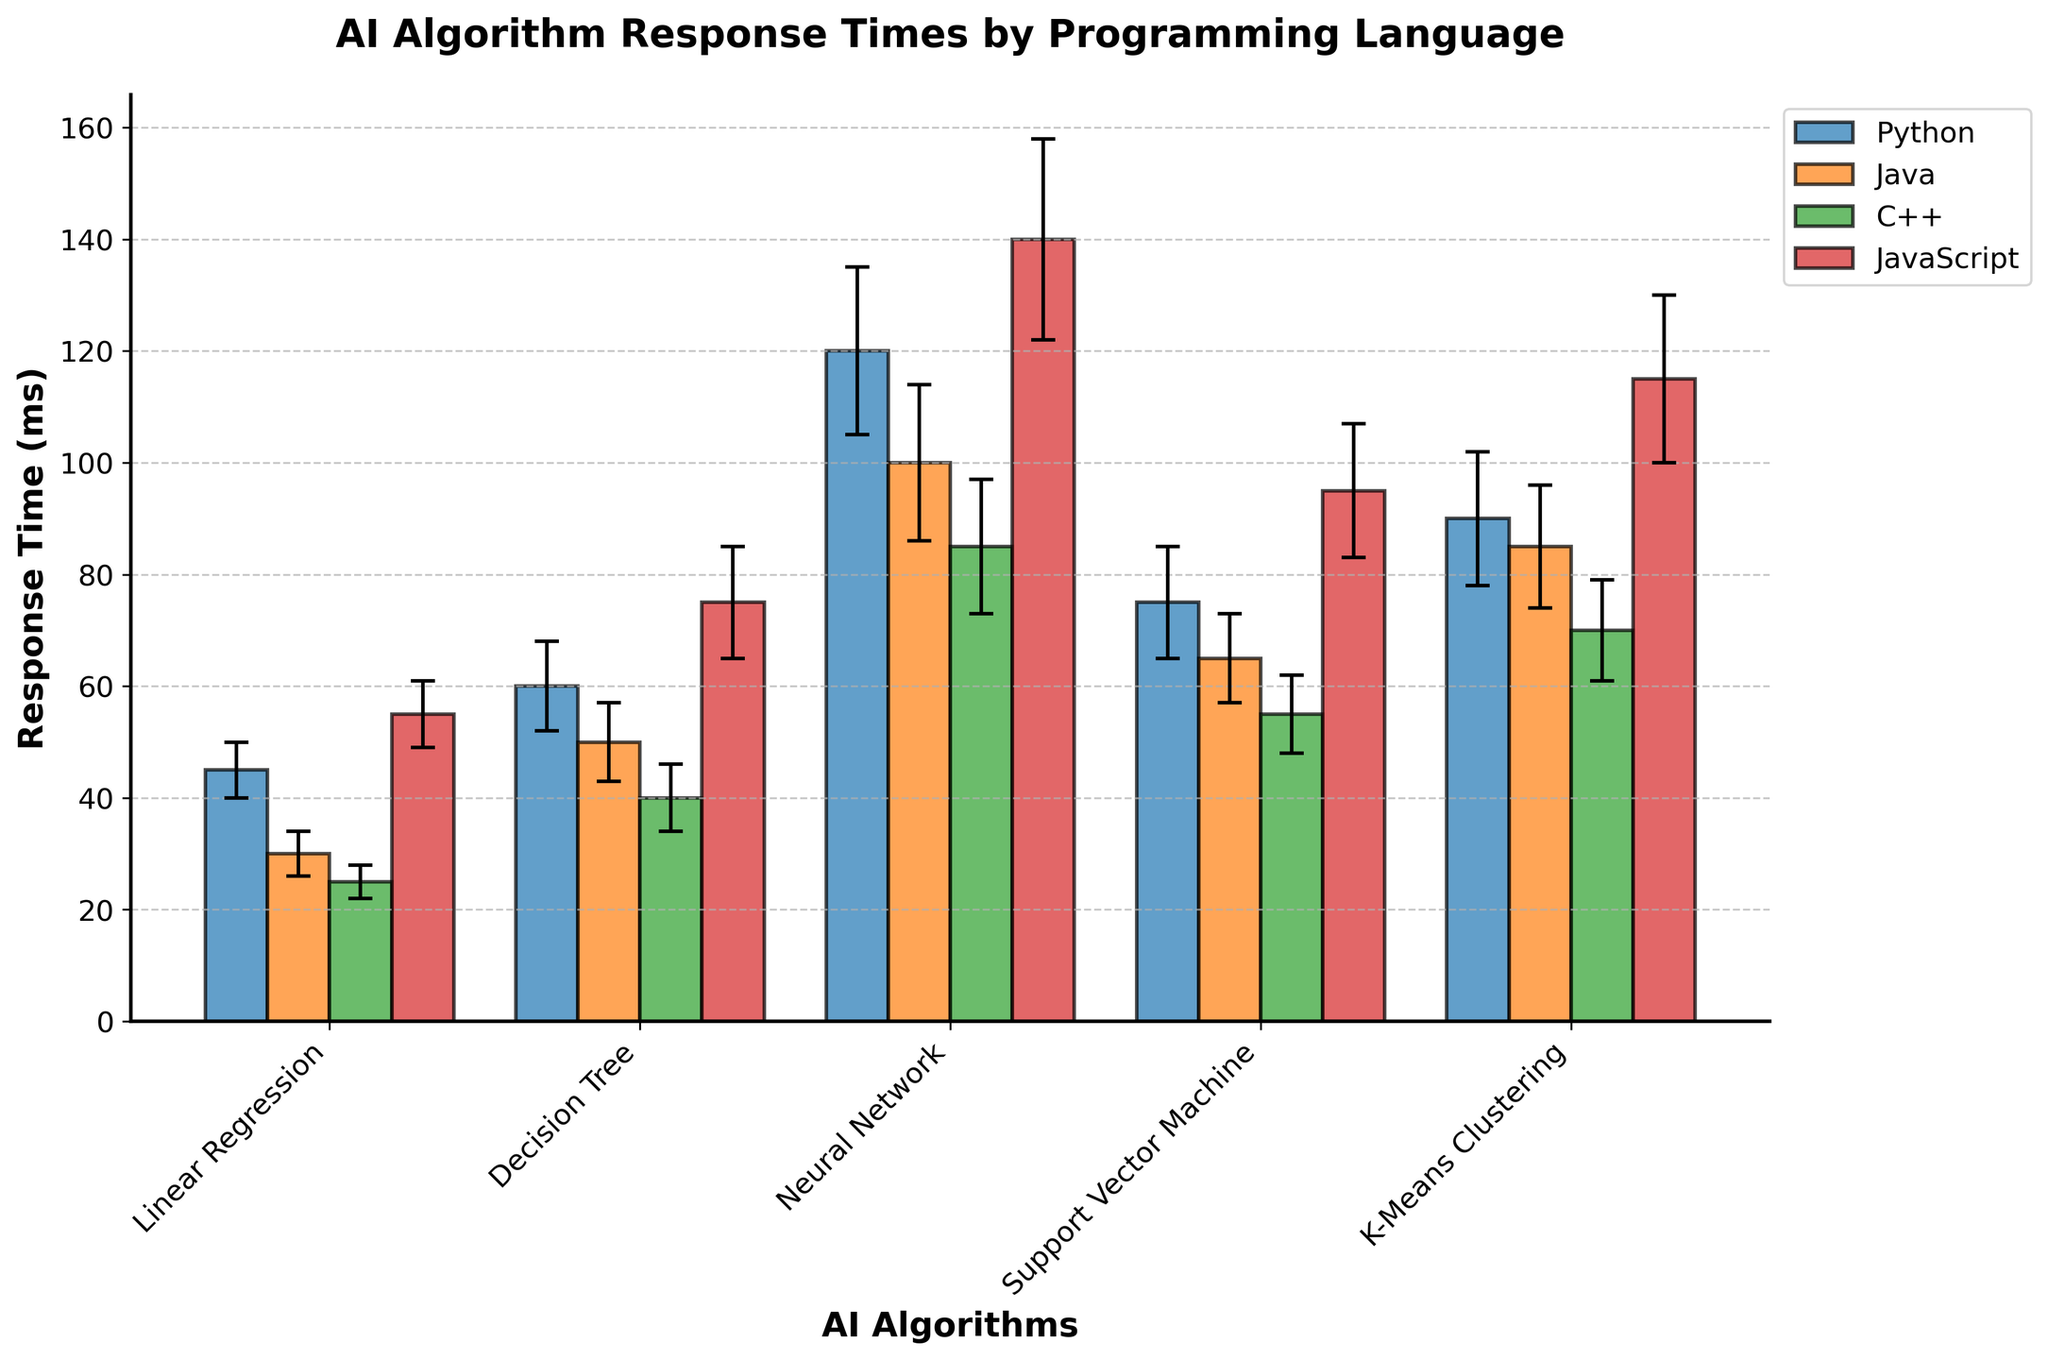What is the title of the figure? The title is at the top of the figure. It reads "AI Algorithm Response Times by Programming Language".
Answer: AI Algorithm Response Times by Programming Language Which language has the highest mean response time for the Neural Network algorithm? From the plot, the bar representing JavaScript for the Neural Network algorithm is the highest among the four languages.
Answer: JavaScript What is the mean response time of Java for the K-Means Clustering algorithm? The plot shows the height of the bar representing Java for the K-Means Clustering algorithm, which is aligned with the y-axis value at 85 ms.
Answer: 85 ms How much higher is the mean response time of Python compared to C++ for the Support Vector Machine algorithm? For Python, the mean response time for Support Vector Machine is 75 ms, and for C++, it is 55 ms. The difference is 75 ms - 55 ms = 20 ms.
Answer: 20 ms Which algorithm has the smallest standard deviation in response time for all four languages? By inspecting the error bars for each algorithm, the Linear Regression algorithm has the smallest error bars, indicating the smallest standard deviation across all languages.
Answer: Linear Regression Which language shows the greatest variability in mean response times across all algorithms? JavaScript shows the largest error bars across most algorithms, indicating the greatest variability in mean response times.
Answer: JavaScript For the Decision Tree algorithm, which language has the least response time, and what is its value? The plot shows that C++ has the shortest bar for the Decision Tree algorithm, indicating the least response time. The value is aligned with the y-axis at 40 ms.
Answer: C++, 40 ms Among the Linear Regression and K-Means Clustering algorithms, which one has the higher mean response time for the language Java? For Java, the Linear Regression mean response time is 30 ms, and the K-Means Clustering mean response time is 85 ms. Thus, K-Means Clustering has the higher mean response time.
Answer: K-Means Clustering What is the mean difference between Python and JavaScript for the Neural Network algorithm? For Python, the mean response time for Neural Network is 120 ms. For JavaScript, it is 140 ms. The difference is 140 ms - 120 ms = 20 ms.
Answer: 20 ms 